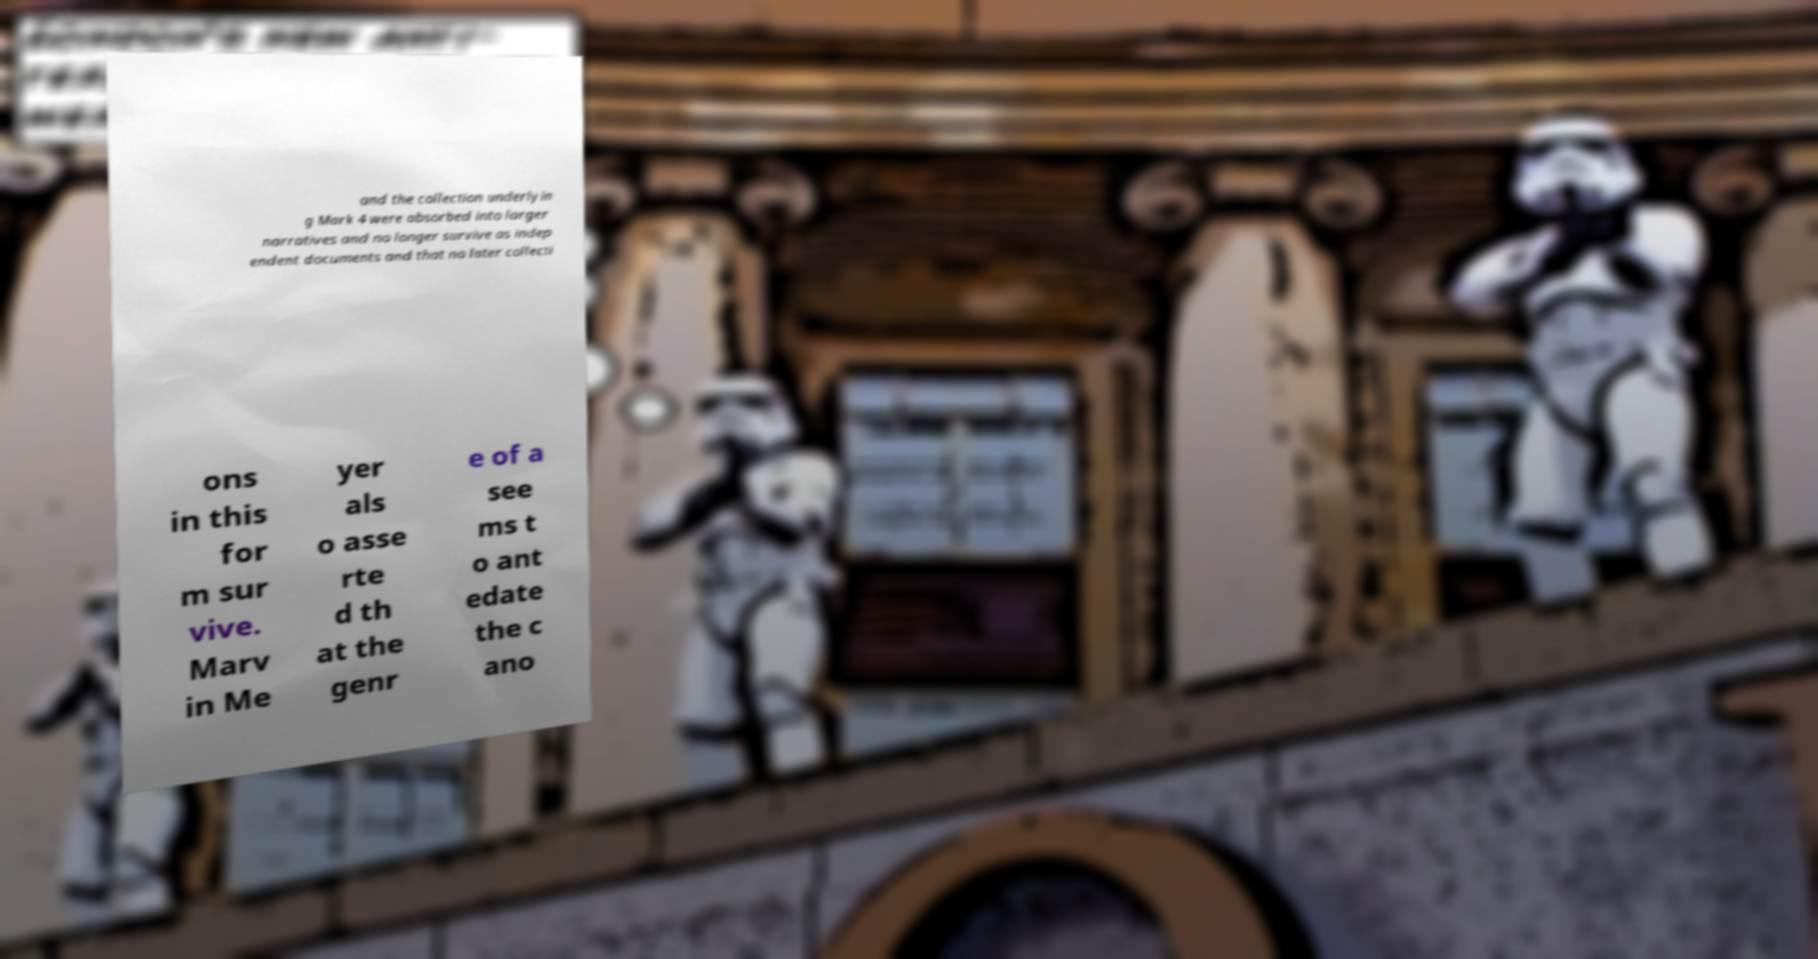Please identify and transcribe the text found in this image. and the collection underlyin g Mark 4 were absorbed into larger narratives and no longer survive as indep endent documents and that no later collecti ons in this for m sur vive. Marv in Me yer als o asse rte d th at the genr e of a see ms t o ant edate the c ano 